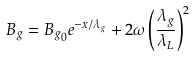<formula> <loc_0><loc_0><loc_500><loc_500>B _ { g } = { B _ { g } } _ { 0 } e ^ { - x / \lambda _ { g } } + 2 \omega \left ( \frac { \lambda _ { g } } { \lambda _ { L } } \right ) ^ { 2 }</formula> 